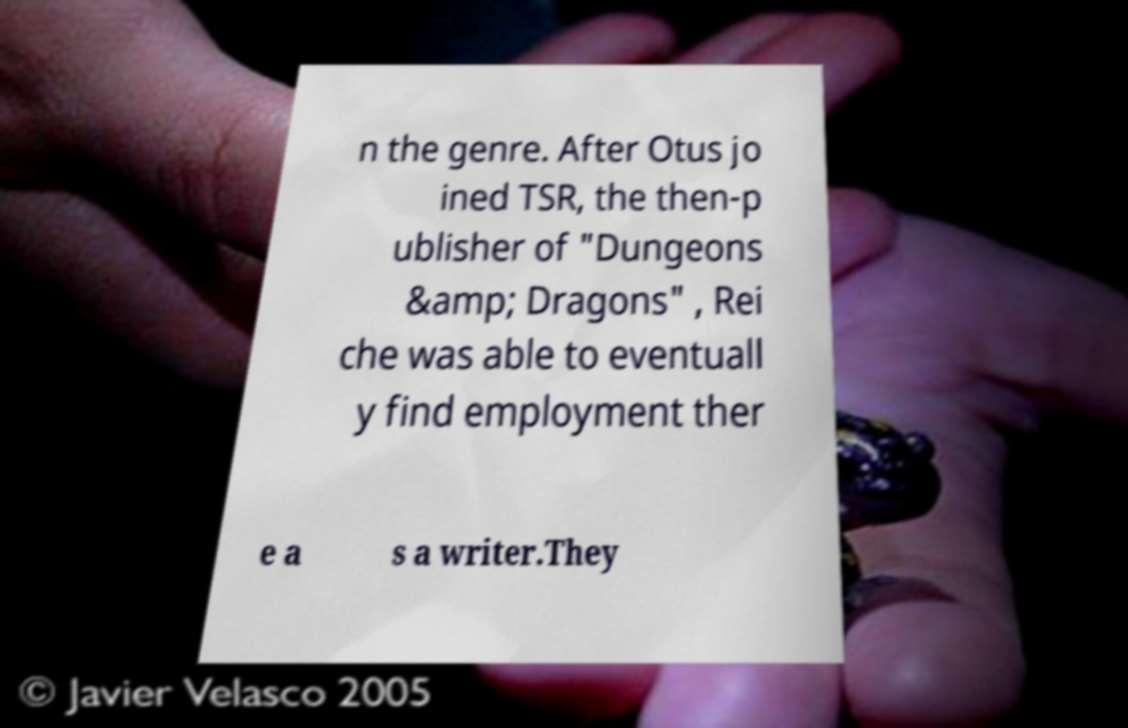I need the written content from this picture converted into text. Can you do that? n the genre. After Otus jo ined TSR, the then-p ublisher of "Dungeons &amp; Dragons" , Rei che was able to eventuall y find employment ther e a s a writer.They 